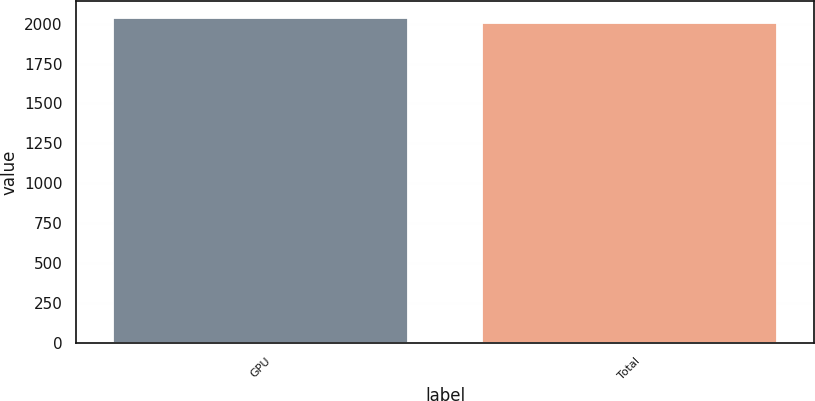<chart> <loc_0><loc_0><loc_500><loc_500><bar_chart><fcel>GPU<fcel>Total<nl><fcel>2038<fcel>2002<nl></chart> 